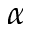Convert formula to latex. <formula><loc_0><loc_0><loc_500><loc_500>\alpha</formula> 